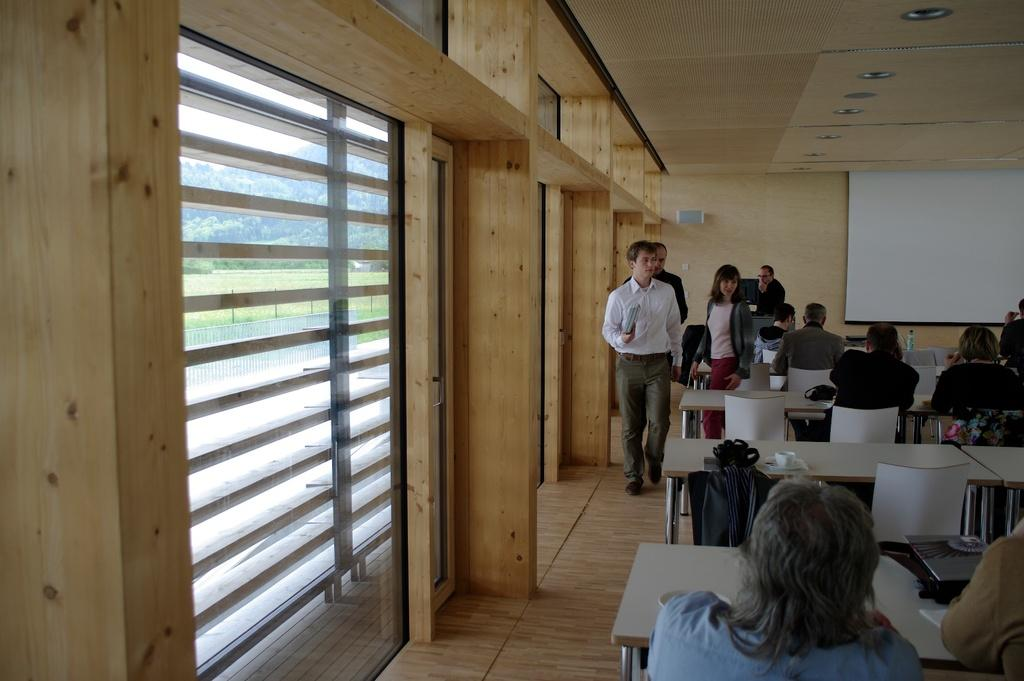What are the persons in the image doing? Some persons are sitting on chairs, and some are standing on the floor in the image. What can be seen in the background of the image? There is a display screen, blinds, the ground, trees, and the sky visible in the background of the image. What type of coat is the wave wearing in the image? There is no wave or coat present in the image. How low is the ground in the image? The ground is not described as being high or low in the image; it is simply visible in the background. 